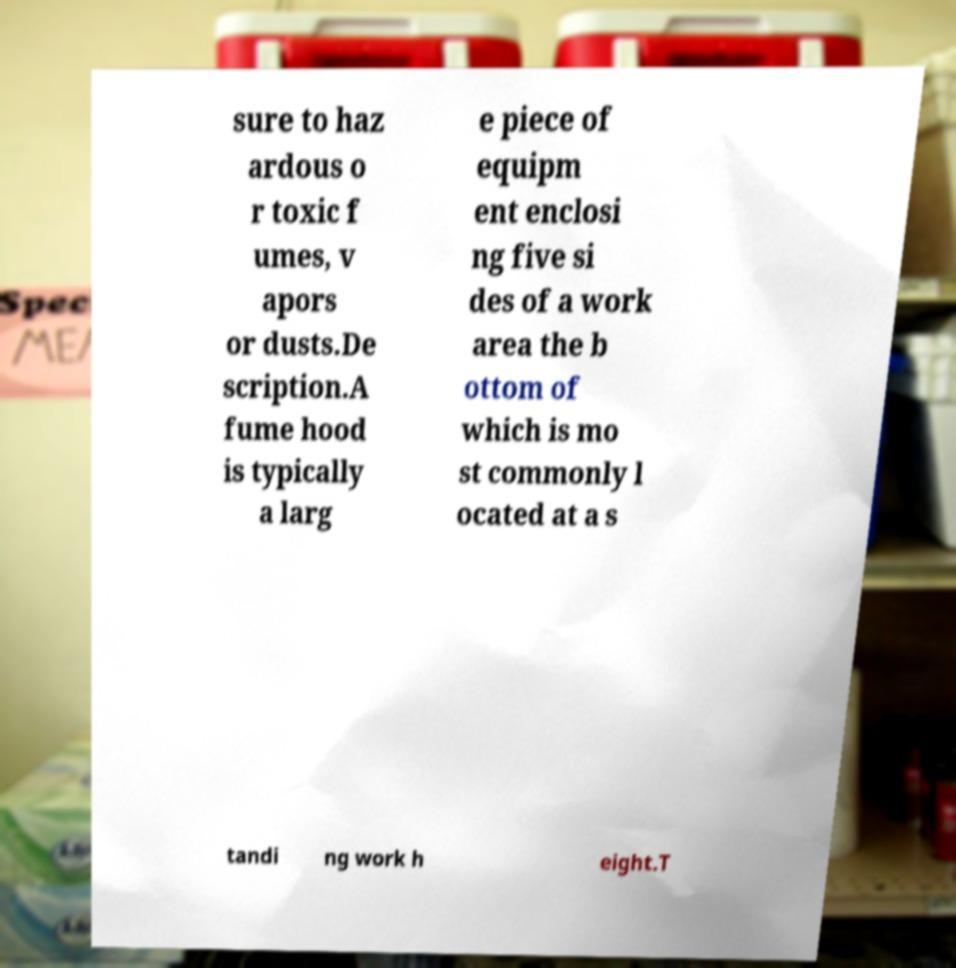Can you read and provide the text displayed in the image?This photo seems to have some interesting text. Can you extract and type it out for me? sure to haz ardous o r toxic f umes, v apors or dusts.De scription.A fume hood is typically a larg e piece of equipm ent enclosi ng five si des of a work area the b ottom of which is mo st commonly l ocated at a s tandi ng work h eight.T 